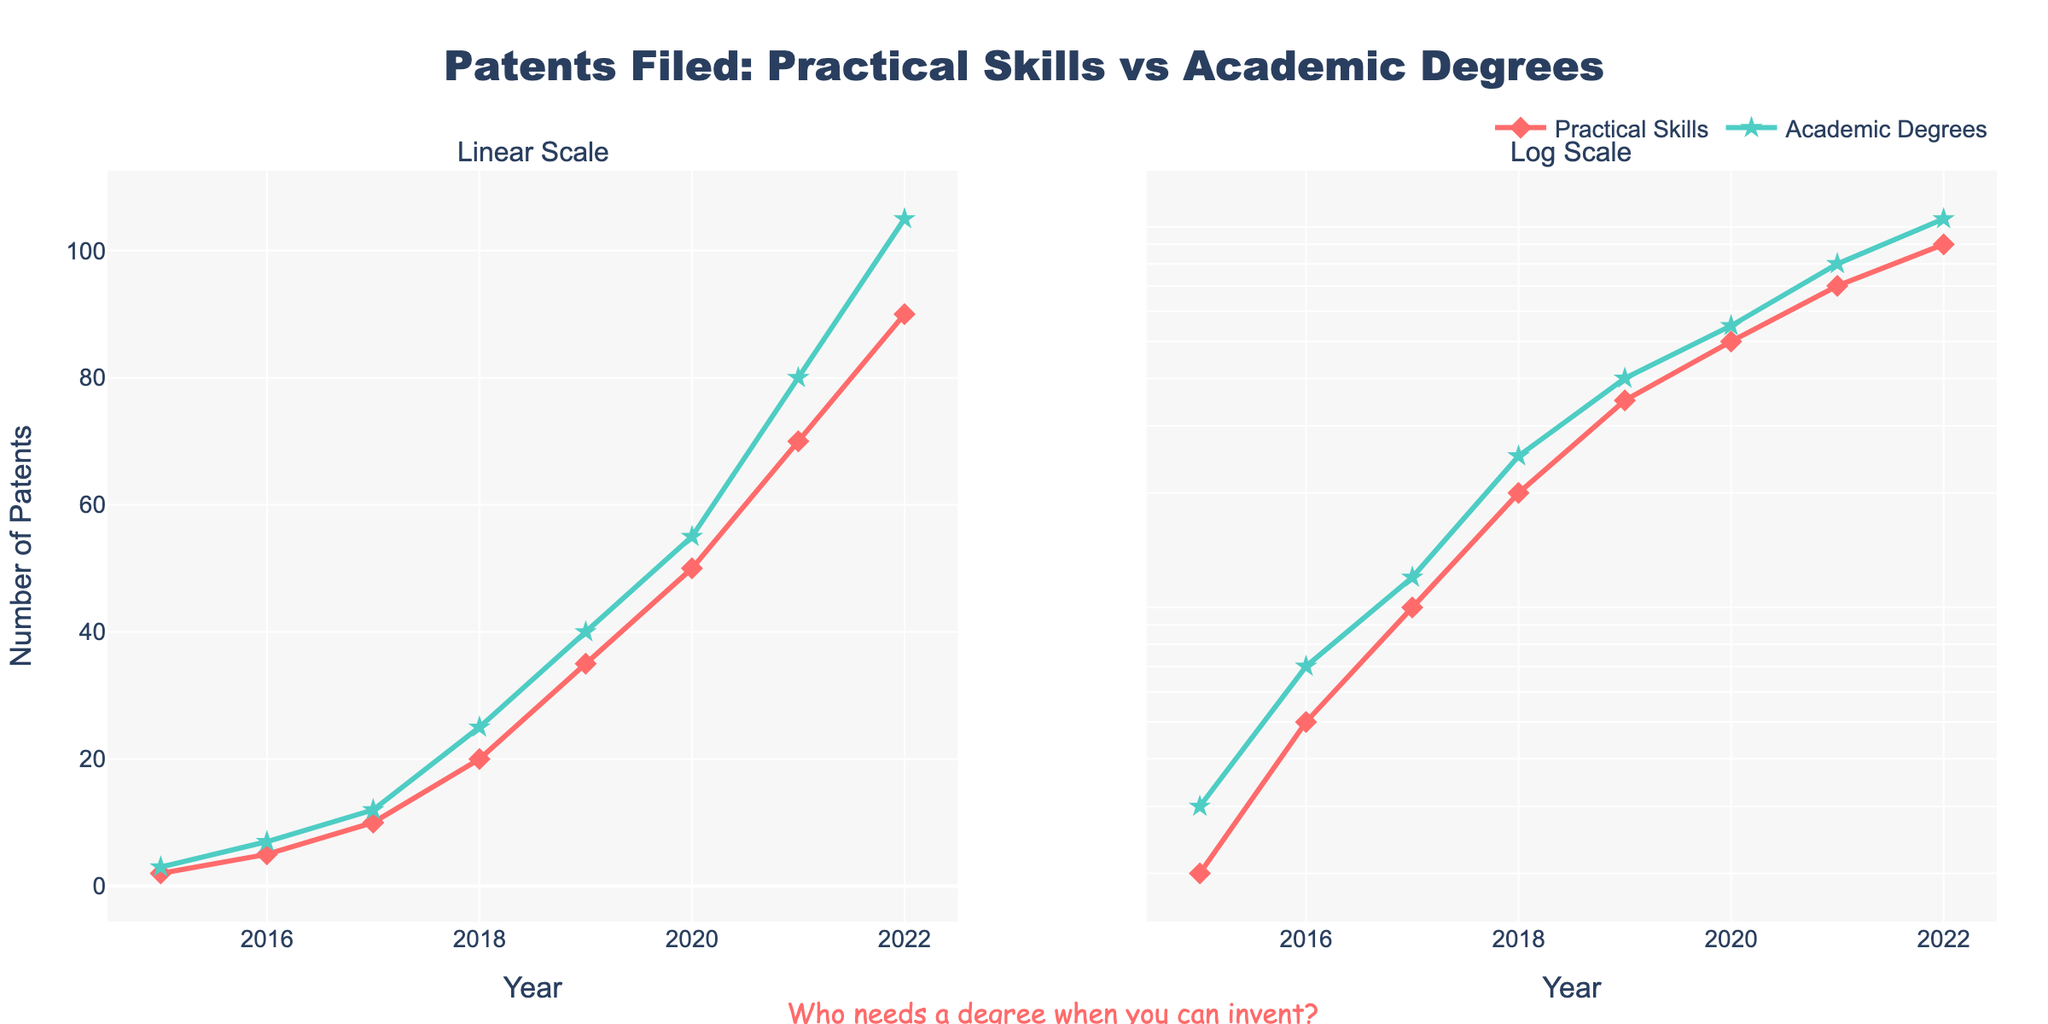How many years of data are depicted in the figure? The X-axis represents the year from 2015 to 2022, so we simply count these years. This is 2022 - 2015 + 1 = 8 years.
Answer: 8 Which category had a higher number of patents in 2022? In 2022, the data points for Practical Skills and Academic Degrees are 90 and 105 respectively. Since 105 is greater than 90, Academic Degrees had a higher number of patents.
Answer: Academic Degrees On the log scale subplot, what is the approximate number of patents filed by Practical Skills in 2020? Find the 2020 data point for Practical Skills on the log scale subplot. The marker is near 50.
Answer: 50 What is the difference in the number of patents filed between Practical Skills and Academic Degrees in 2019? Look at both categories' data points for 2019. Practical Skills have 35, and Academic Degrees have 40. The difference is 40 - 35 = 5.
Answer: 5 How much did the number of patents filed by people with Practical Skills increase from 2016 to 2017? For Practical Skills, the number of patents in 2016 is 5 and in 2017 is 10. The increase is 10 - 5 = 5.
Answer: 5 Which subplot looks more linear, the linear or the log scale? The linear scale subplot shows a more curved trend, while the log scale subplot shows a more linear trend for both categories.
Answer: Log scale What is the combined total of patents filed by both groups in 2015? Add the 2015 data points for both categories. Practical Skills: 2, Academic Degrees: 3, total is 2 + 3 = 5.
Answer: 5 By which year did the number of patents filed by Practical Skills individuals reach at least 20? Trace the Practical Skills' points and see it first reaches at least 20 in 2018.
Answer: 2018 What is the average number of patents filed by people with Academic Degrees over the entire period? Add the patents for Academic Degrees (3, 7, 12, 25, 40, 55, 80, 105) and divide by 8 (years). (3+7+12+25+40+55+80+105) / 8 = 40.875
Answer: 40.875 Which category shows a higher growth rate in the number of patents, judging by the log scale subplot? Compare the slopes of the two lines in the log scale subplot. The slope for Academic Degrees is steeper, indicating a higher growth rate.
Answer: Academic Degrees 